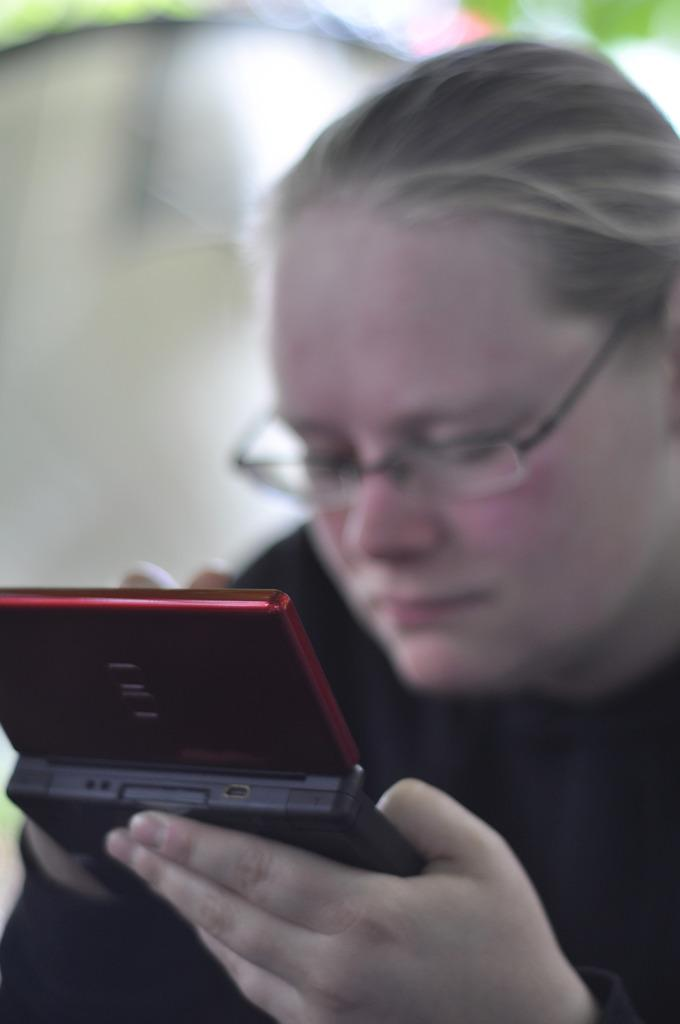What is the main subject of the image? There is a person in the image. What is the person wearing? The person is wearing a black dress. What accessory is the person wearing? The person is wearing spectacles. What is the person holding in their hands? The person is holding a mobile phone in their hands. What is the person doing with the mobile phone? The person is operating the mobile phone. What type of cat can be seen reading the news in the image? There is no cat or news present in the image; it features a person holding and operating a mobile phone. What kind of pest is the person trying to get rid of in the image? There is no indication of a pest in the image; the person is simply operating a mobile phone. 